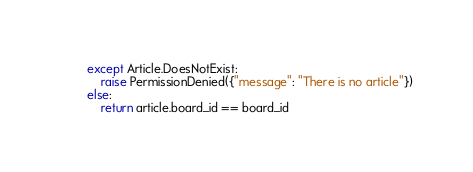Convert code to text. <code><loc_0><loc_0><loc_500><loc_500><_Python_>        except Article.DoesNotExist:
            raise PermissionDenied({"message": "There is no article"})
        else:
            return article.board_id == board_id

</code> 